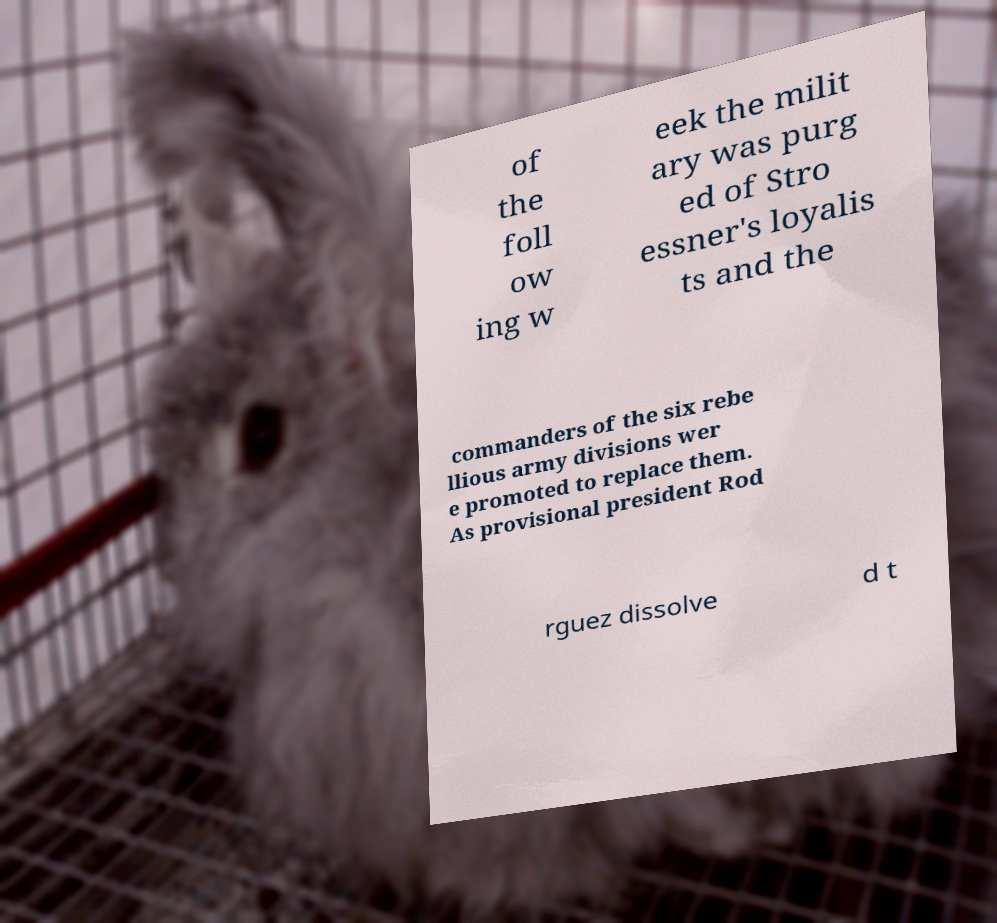Could you extract and type out the text from this image? of the foll ow ing w eek the milit ary was purg ed of Stro essner's loyalis ts and the commanders of the six rebe llious army divisions wer e promoted to replace them. As provisional president Rod rguez dissolve d t 